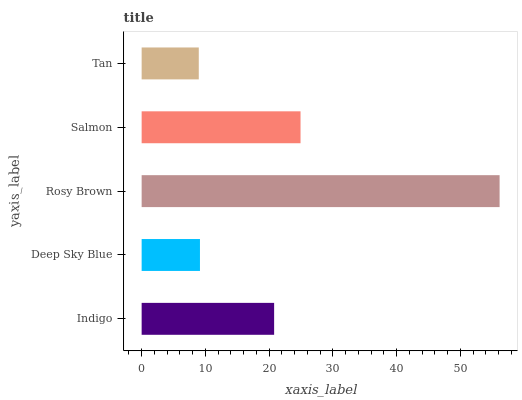Is Tan the minimum?
Answer yes or no. Yes. Is Rosy Brown the maximum?
Answer yes or no. Yes. Is Deep Sky Blue the minimum?
Answer yes or no. No. Is Deep Sky Blue the maximum?
Answer yes or no. No. Is Indigo greater than Deep Sky Blue?
Answer yes or no. Yes. Is Deep Sky Blue less than Indigo?
Answer yes or no. Yes. Is Deep Sky Blue greater than Indigo?
Answer yes or no. No. Is Indigo less than Deep Sky Blue?
Answer yes or no. No. Is Indigo the high median?
Answer yes or no. Yes. Is Indigo the low median?
Answer yes or no. Yes. Is Salmon the high median?
Answer yes or no. No. Is Tan the low median?
Answer yes or no. No. 